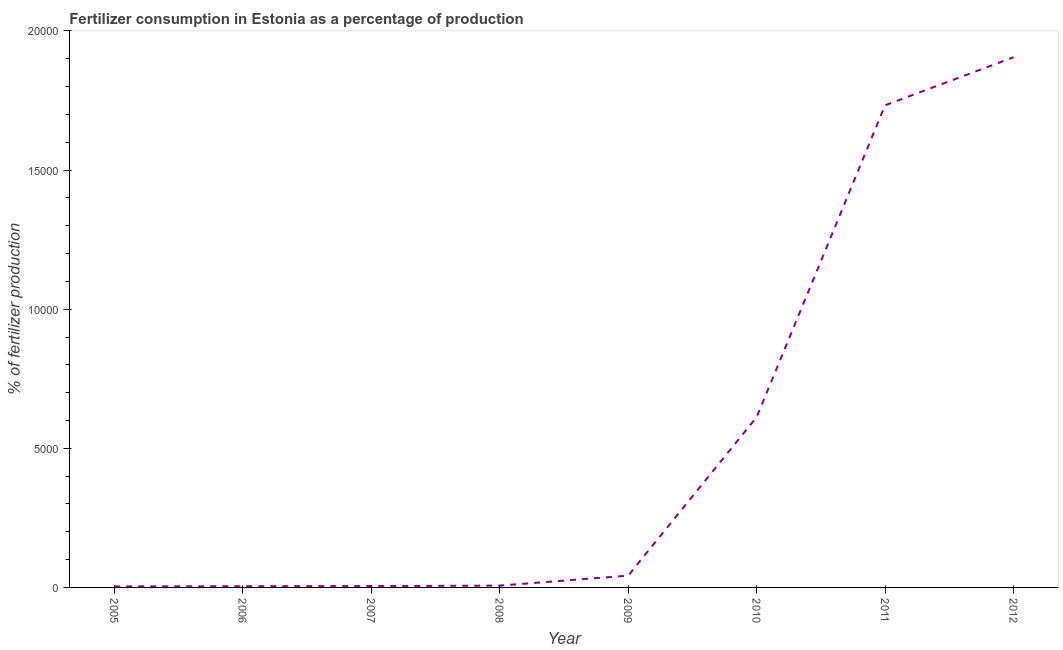What is the amount of fertilizer consumption in 2009?
Offer a terse response. 423.12. Across all years, what is the maximum amount of fertilizer consumption?
Provide a succinct answer. 1.91e+04. Across all years, what is the minimum amount of fertilizer consumption?
Your answer should be compact. 35.72. In which year was the amount of fertilizer consumption maximum?
Your answer should be very brief. 2012. What is the sum of the amount of fertilizer consumption?
Give a very brief answer. 4.31e+04. What is the difference between the amount of fertilizer consumption in 2006 and 2011?
Your answer should be compact. -1.73e+04. What is the average amount of fertilizer consumption per year?
Your answer should be very brief. 5389.41. What is the median amount of fertilizer consumption?
Make the answer very short. 244.26. In how many years, is the amount of fertilizer consumption greater than 9000 %?
Offer a very short reply. 2. Do a majority of the years between 2010 and 2006 (inclusive) have amount of fertilizer consumption greater than 10000 %?
Make the answer very short. Yes. What is the ratio of the amount of fertilizer consumption in 2007 to that in 2008?
Make the answer very short. 0.72. Is the amount of fertilizer consumption in 2007 less than that in 2010?
Your answer should be compact. Yes. Is the difference between the amount of fertilizer consumption in 2007 and 2012 greater than the difference between any two years?
Make the answer very short. No. What is the difference between the highest and the second highest amount of fertilizer consumption?
Your answer should be very brief. 1725.81. Is the sum of the amount of fertilizer consumption in 2005 and 2012 greater than the maximum amount of fertilizer consumption across all years?
Keep it short and to the point. Yes. What is the difference between the highest and the lowest amount of fertilizer consumption?
Your answer should be compact. 1.90e+04. In how many years, is the amount of fertilizer consumption greater than the average amount of fertilizer consumption taken over all years?
Your answer should be very brief. 3. How many lines are there?
Give a very brief answer. 1. What is the difference between two consecutive major ticks on the Y-axis?
Offer a terse response. 5000. Are the values on the major ticks of Y-axis written in scientific E-notation?
Your answer should be compact. No. What is the title of the graph?
Keep it short and to the point. Fertilizer consumption in Estonia as a percentage of production. What is the label or title of the X-axis?
Make the answer very short. Year. What is the label or title of the Y-axis?
Provide a short and direct response. % of fertilizer production. What is the % of fertilizer production in 2005?
Your answer should be compact. 35.72. What is the % of fertilizer production of 2006?
Your answer should be very brief. 42.57. What is the % of fertilizer production of 2007?
Keep it short and to the point. 47.17. What is the % of fertilizer production in 2008?
Keep it short and to the point. 65.39. What is the % of fertilizer production in 2009?
Keep it short and to the point. 423.12. What is the % of fertilizer production of 2010?
Your response must be concise. 6118.03. What is the % of fertilizer production of 2011?
Your response must be concise. 1.73e+04. What is the % of fertilizer production of 2012?
Your answer should be very brief. 1.91e+04. What is the difference between the % of fertilizer production in 2005 and 2006?
Offer a terse response. -6.86. What is the difference between the % of fertilizer production in 2005 and 2007?
Provide a short and direct response. -11.45. What is the difference between the % of fertilizer production in 2005 and 2008?
Your answer should be compact. -29.67. What is the difference between the % of fertilizer production in 2005 and 2009?
Provide a succinct answer. -387.4. What is the difference between the % of fertilizer production in 2005 and 2010?
Your answer should be compact. -6082.31. What is the difference between the % of fertilizer production in 2005 and 2011?
Provide a short and direct response. -1.73e+04. What is the difference between the % of fertilizer production in 2005 and 2012?
Your response must be concise. -1.90e+04. What is the difference between the % of fertilizer production in 2006 and 2007?
Offer a very short reply. -4.59. What is the difference between the % of fertilizer production in 2006 and 2008?
Provide a succinct answer. -22.82. What is the difference between the % of fertilizer production in 2006 and 2009?
Your response must be concise. -380.54. What is the difference between the % of fertilizer production in 2006 and 2010?
Make the answer very short. -6075.46. What is the difference between the % of fertilizer production in 2006 and 2011?
Offer a very short reply. -1.73e+04. What is the difference between the % of fertilizer production in 2006 and 2012?
Offer a very short reply. -1.90e+04. What is the difference between the % of fertilizer production in 2007 and 2008?
Give a very brief answer. -18.23. What is the difference between the % of fertilizer production in 2007 and 2009?
Give a very brief answer. -375.95. What is the difference between the % of fertilizer production in 2007 and 2010?
Make the answer very short. -6070.86. What is the difference between the % of fertilizer production in 2007 and 2011?
Your answer should be compact. -1.73e+04. What is the difference between the % of fertilizer production in 2007 and 2012?
Provide a short and direct response. -1.90e+04. What is the difference between the % of fertilizer production in 2008 and 2009?
Ensure brevity in your answer.  -357.73. What is the difference between the % of fertilizer production in 2008 and 2010?
Your answer should be very brief. -6052.64. What is the difference between the % of fertilizer production in 2008 and 2011?
Ensure brevity in your answer.  -1.73e+04. What is the difference between the % of fertilizer production in 2008 and 2012?
Your answer should be compact. -1.90e+04. What is the difference between the % of fertilizer production in 2009 and 2010?
Make the answer very short. -5694.91. What is the difference between the % of fertilizer production in 2009 and 2011?
Provide a short and direct response. -1.69e+04. What is the difference between the % of fertilizer production in 2009 and 2012?
Your answer should be very brief. -1.86e+04. What is the difference between the % of fertilizer production in 2010 and 2011?
Your answer should be compact. -1.12e+04. What is the difference between the % of fertilizer production in 2010 and 2012?
Offer a very short reply. -1.29e+04. What is the difference between the % of fertilizer production in 2011 and 2012?
Make the answer very short. -1725.81. What is the ratio of the % of fertilizer production in 2005 to that in 2006?
Provide a succinct answer. 0.84. What is the ratio of the % of fertilizer production in 2005 to that in 2007?
Give a very brief answer. 0.76. What is the ratio of the % of fertilizer production in 2005 to that in 2008?
Keep it short and to the point. 0.55. What is the ratio of the % of fertilizer production in 2005 to that in 2009?
Your response must be concise. 0.08. What is the ratio of the % of fertilizer production in 2005 to that in 2010?
Ensure brevity in your answer.  0.01. What is the ratio of the % of fertilizer production in 2005 to that in 2011?
Provide a succinct answer. 0. What is the ratio of the % of fertilizer production in 2005 to that in 2012?
Provide a succinct answer. 0. What is the ratio of the % of fertilizer production in 2006 to that in 2007?
Make the answer very short. 0.9. What is the ratio of the % of fertilizer production in 2006 to that in 2008?
Give a very brief answer. 0.65. What is the ratio of the % of fertilizer production in 2006 to that in 2009?
Your answer should be compact. 0.1. What is the ratio of the % of fertilizer production in 2006 to that in 2010?
Your response must be concise. 0.01. What is the ratio of the % of fertilizer production in 2006 to that in 2011?
Your response must be concise. 0. What is the ratio of the % of fertilizer production in 2006 to that in 2012?
Keep it short and to the point. 0. What is the ratio of the % of fertilizer production in 2007 to that in 2008?
Offer a terse response. 0.72. What is the ratio of the % of fertilizer production in 2007 to that in 2009?
Your response must be concise. 0.11. What is the ratio of the % of fertilizer production in 2007 to that in 2010?
Ensure brevity in your answer.  0.01. What is the ratio of the % of fertilizer production in 2007 to that in 2011?
Your answer should be very brief. 0. What is the ratio of the % of fertilizer production in 2007 to that in 2012?
Offer a very short reply. 0. What is the ratio of the % of fertilizer production in 2008 to that in 2009?
Make the answer very short. 0.15. What is the ratio of the % of fertilizer production in 2008 to that in 2010?
Your answer should be compact. 0.01. What is the ratio of the % of fertilizer production in 2008 to that in 2011?
Your answer should be compact. 0. What is the ratio of the % of fertilizer production in 2008 to that in 2012?
Offer a very short reply. 0. What is the ratio of the % of fertilizer production in 2009 to that in 2010?
Make the answer very short. 0.07. What is the ratio of the % of fertilizer production in 2009 to that in 2011?
Your response must be concise. 0.02. What is the ratio of the % of fertilizer production in 2009 to that in 2012?
Your response must be concise. 0.02. What is the ratio of the % of fertilizer production in 2010 to that in 2011?
Keep it short and to the point. 0.35. What is the ratio of the % of fertilizer production in 2010 to that in 2012?
Provide a succinct answer. 0.32. What is the ratio of the % of fertilizer production in 2011 to that in 2012?
Ensure brevity in your answer.  0.91. 